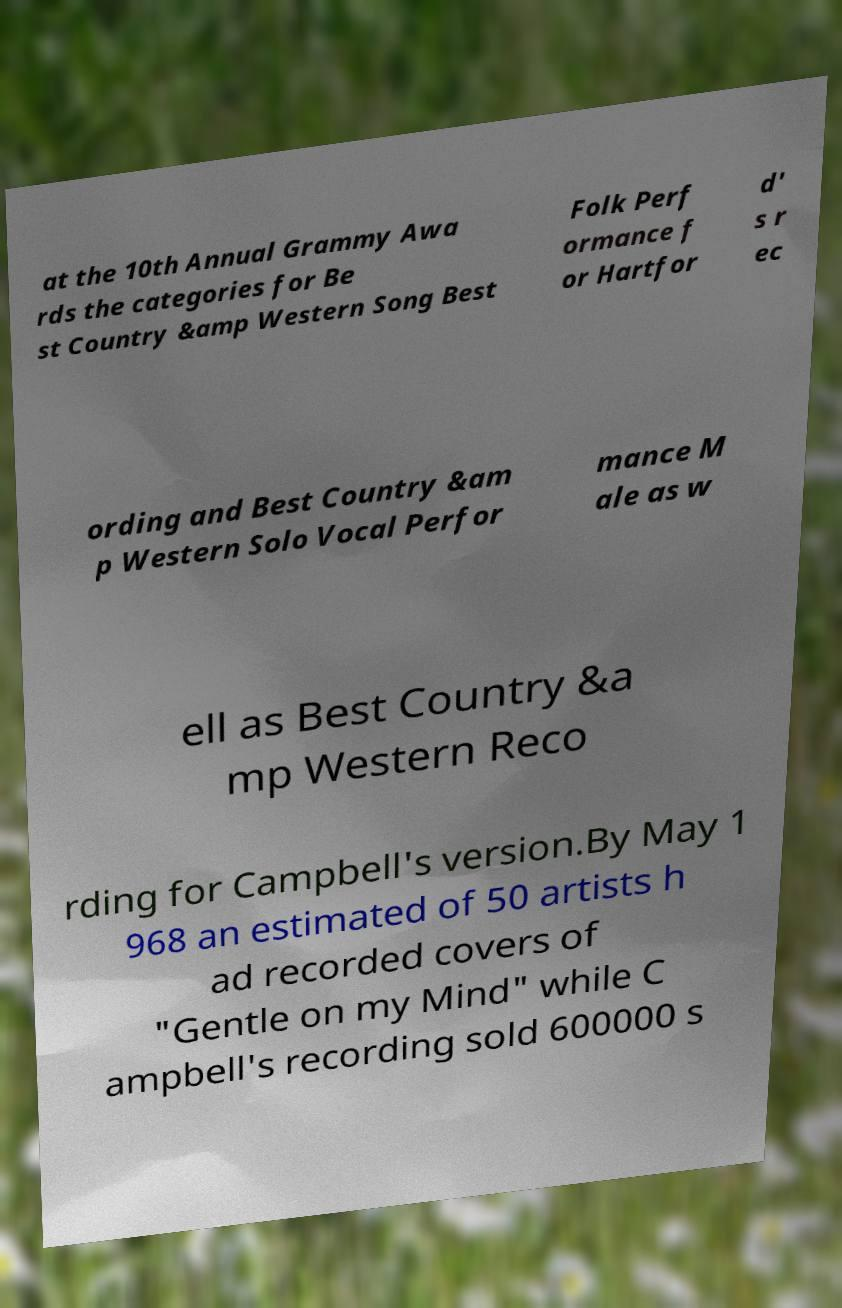Can you read and provide the text displayed in the image?This photo seems to have some interesting text. Can you extract and type it out for me? at the 10th Annual Grammy Awa rds the categories for Be st Country &amp Western Song Best Folk Perf ormance f or Hartfor d' s r ec ording and Best Country &am p Western Solo Vocal Perfor mance M ale as w ell as Best Country &a mp Western Reco rding for Campbell's version.By May 1 968 an estimated of 50 artists h ad recorded covers of "Gentle on my Mind" while C ampbell's recording sold 600000 s 